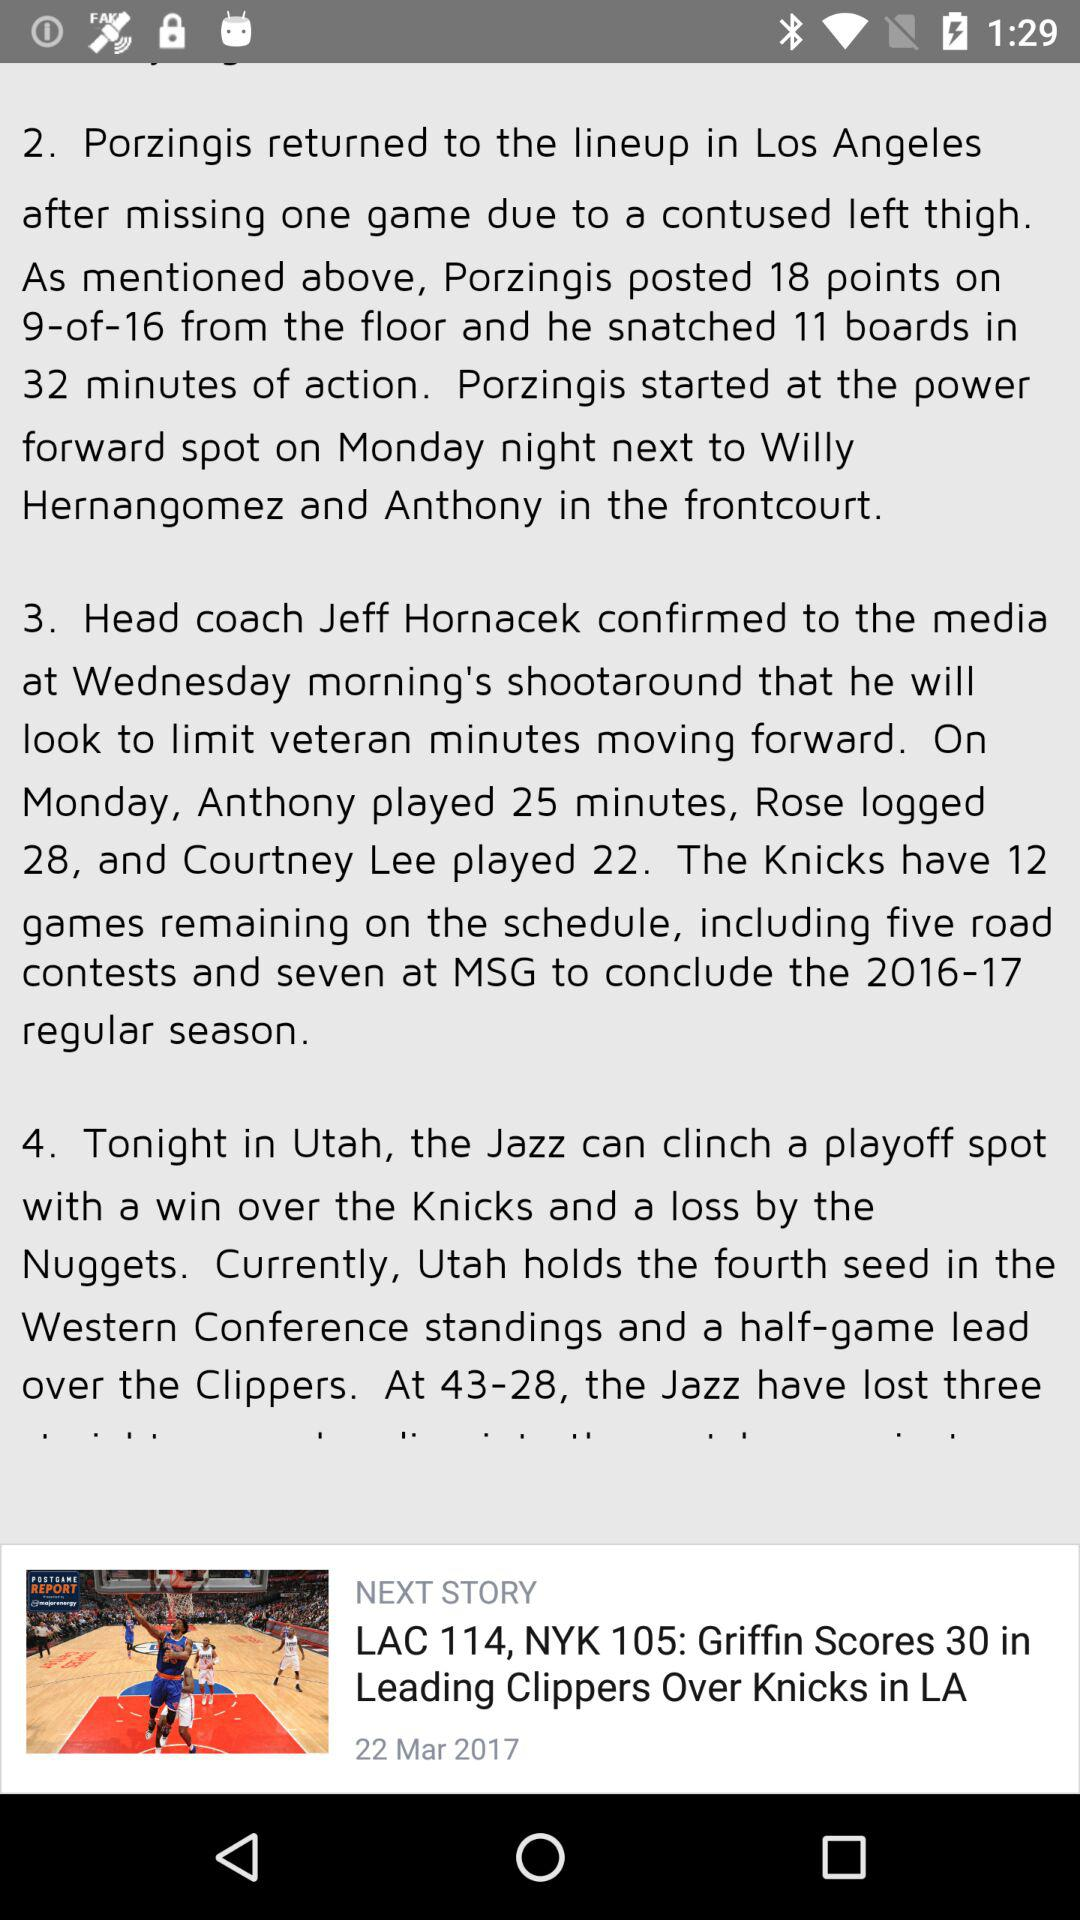How many games are left in the season for the Knicks?
Answer the question using a single word or phrase. 12 